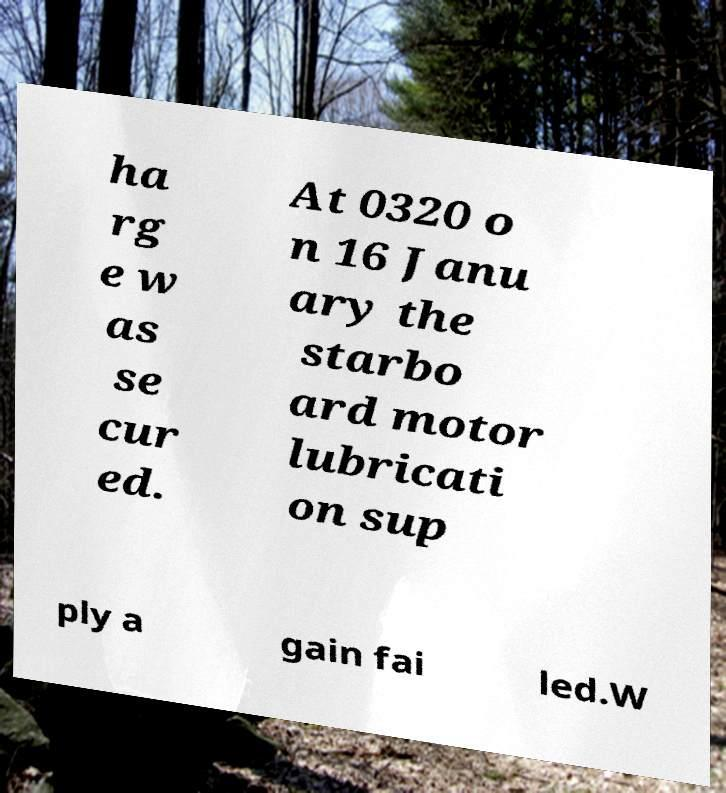Could you extract and type out the text from this image? ha rg e w as se cur ed. At 0320 o n 16 Janu ary the starbo ard motor lubricati on sup ply a gain fai led.W 